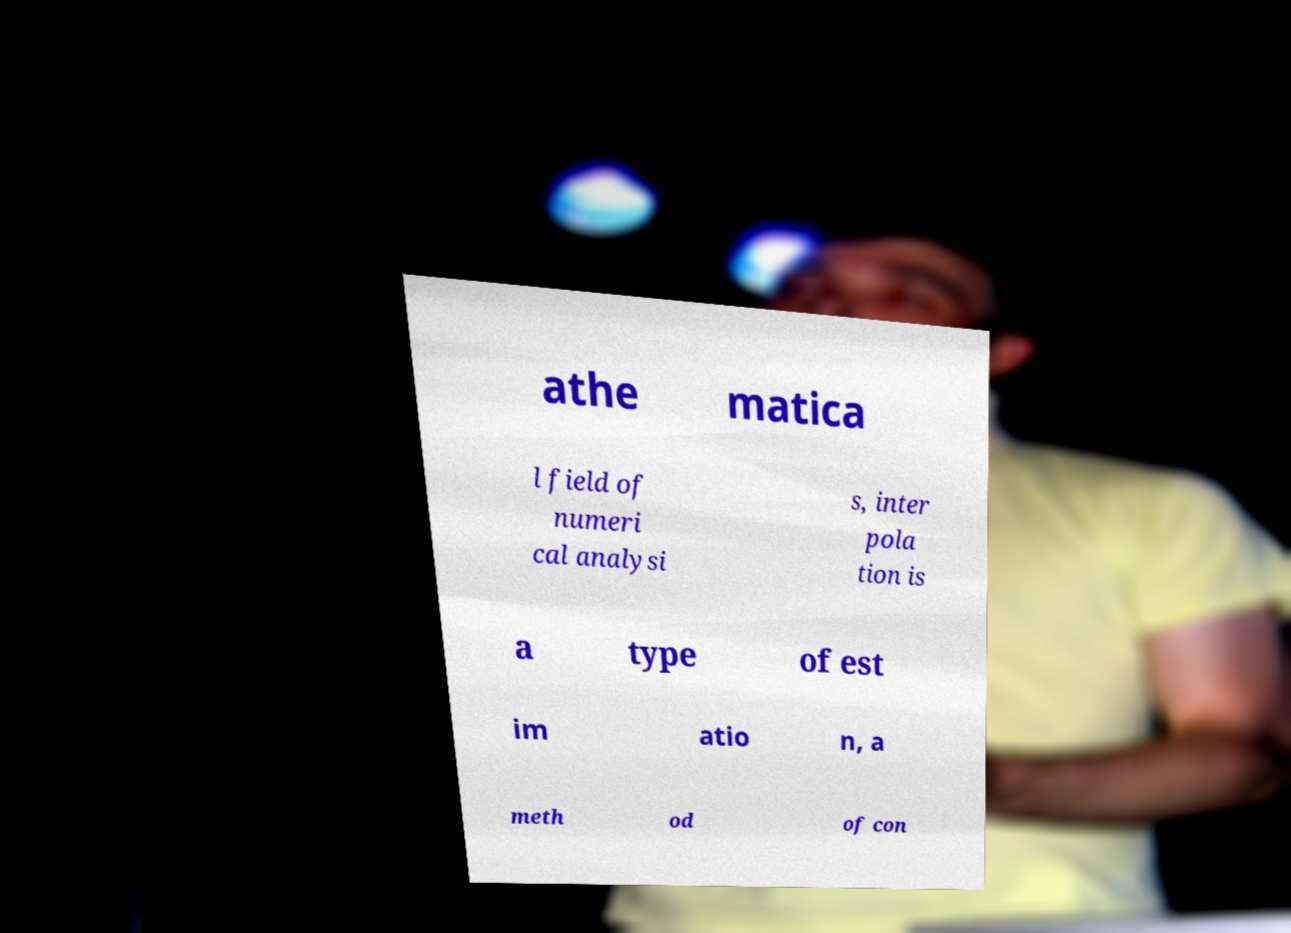Could you extract and type out the text from this image? athe matica l field of numeri cal analysi s, inter pola tion is a type of est im atio n, a meth od of con 